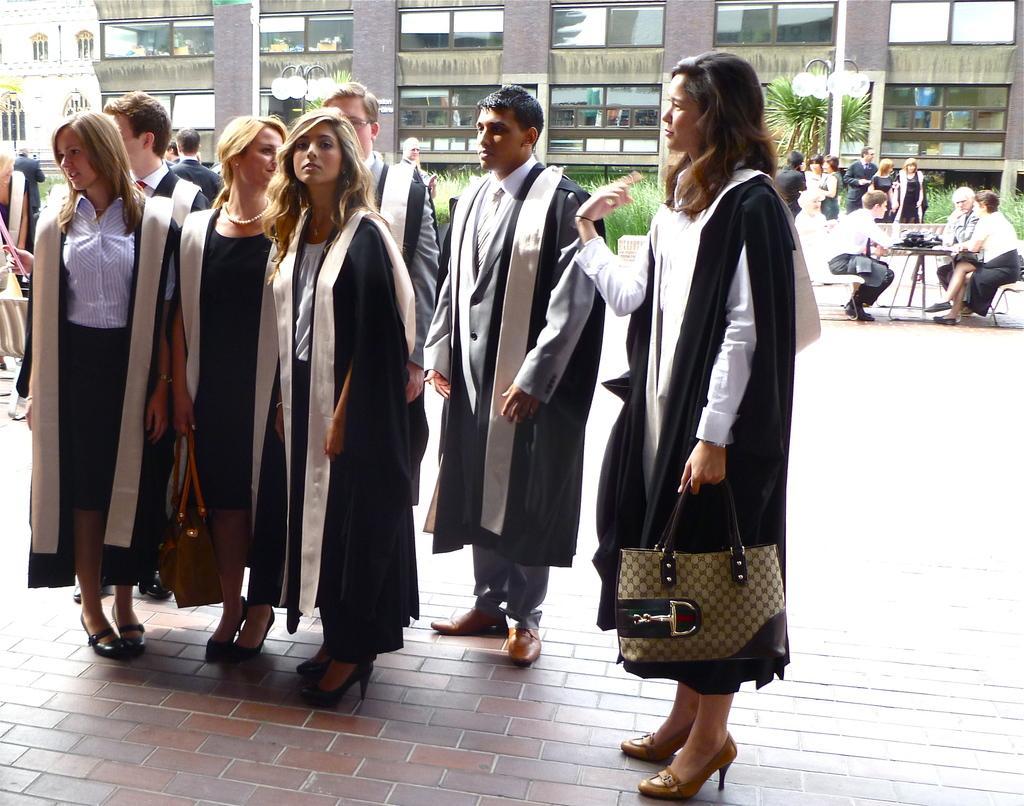Please provide a concise description of this image. In this picture we can see a group of people standing holding their bags and in background we can see building with windows, trees, pole, lamp, table, chairs some are sitting on it. 